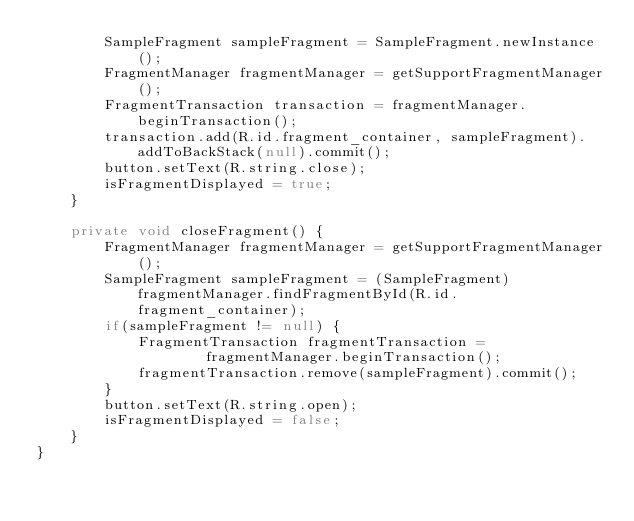<code> <loc_0><loc_0><loc_500><loc_500><_Java_>        SampleFragment sampleFragment = SampleFragment.newInstance();
        FragmentManager fragmentManager = getSupportFragmentManager();
        FragmentTransaction transaction = fragmentManager.beginTransaction();
        transaction.add(R.id.fragment_container, sampleFragment).addToBackStack(null).commit();
        button.setText(R.string.close);
        isFragmentDisplayed = true;
    }

    private void closeFragment() {
        FragmentManager fragmentManager = getSupportFragmentManager();
        SampleFragment sampleFragment = (SampleFragment) fragmentManager.findFragmentById(R.id.fragment_container);
        if(sampleFragment != null) {
            FragmentTransaction fragmentTransaction =
                    fragmentManager.beginTransaction();
            fragmentTransaction.remove(sampleFragment).commit();
        }
        button.setText(R.string.open);
        isFragmentDisplayed = false;
    }
}
</code> 